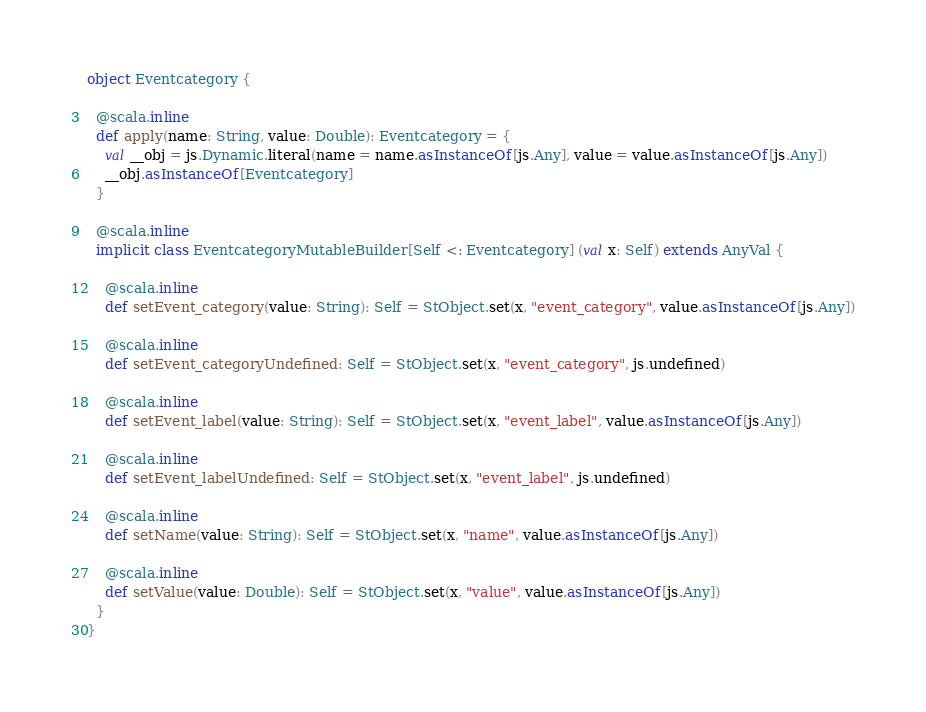Convert code to text. <code><loc_0><loc_0><loc_500><loc_500><_Scala_>object Eventcategory {
  
  @scala.inline
  def apply(name: String, value: Double): Eventcategory = {
    val __obj = js.Dynamic.literal(name = name.asInstanceOf[js.Any], value = value.asInstanceOf[js.Any])
    __obj.asInstanceOf[Eventcategory]
  }
  
  @scala.inline
  implicit class EventcategoryMutableBuilder[Self <: Eventcategory] (val x: Self) extends AnyVal {
    
    @scala.inline
    def setEvent_category(value: String): Self = StObject.set(x, "event_category", value.asInstanceOf[js.Any])
    
    @scala.inline
    def setEvent_categoryUndefined: Self = StObject.set(x, "event_category", js.undefined)
    
    @scala.inline
    def setEvent_label(value: String): Self = StObject.set(x, "event_label", value.asInstanceOf[js.Any])
    
    @scala.inline
    def setEvent_labelUndefined: Self = StObject.set(x, "event_label", js.undefined)
    
    @scala.inline
    def setName(value: String): Self = StObject.set(x, "name", value.asInstanceOf[js.Any])
    
    @scala.inline
    def setValue(value: Double): Self = StObject.set(x, "value", value.asInstanceOf[js.Any])
  }
}
</code> 